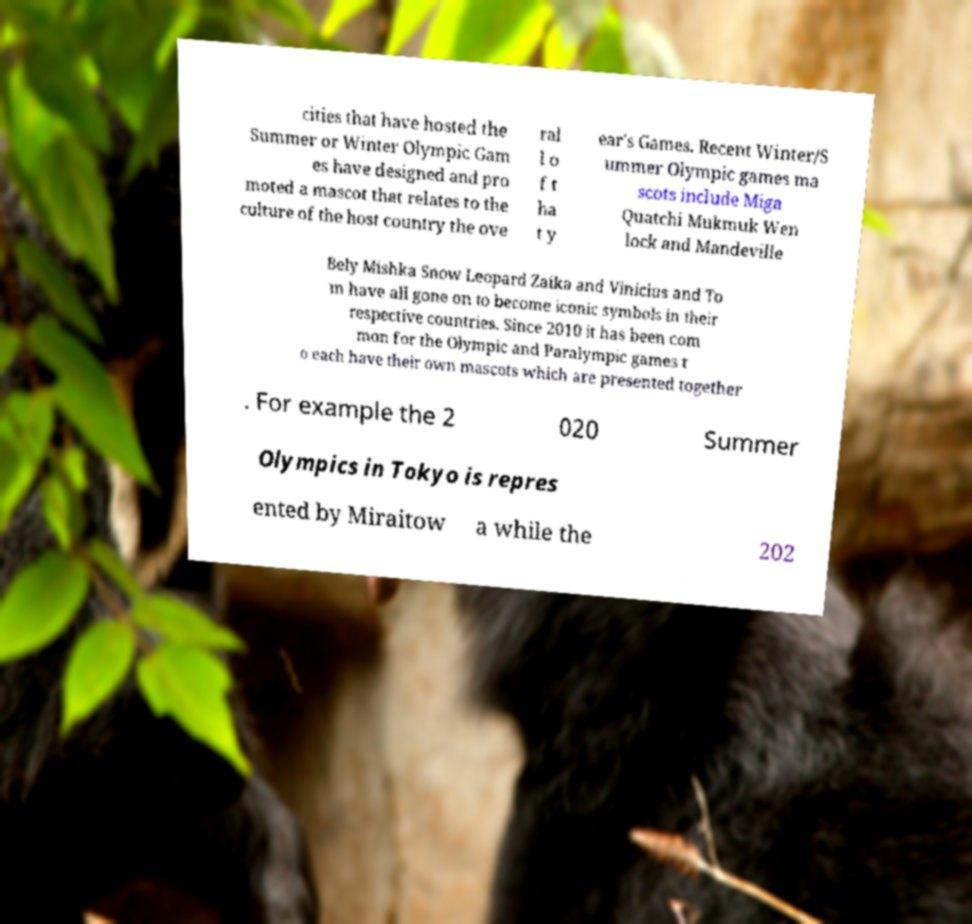Could you extract and type out the text from this image? cities that have hosted the Summer or Winter Olympic Gam es have designed and pro moted a mascot that relates to the culture of the host country the ove ral l o f t ha t y ear's Games. Recent Winter/S ummer Olympic games ma scots include Miga Quatchi Mukmuk Wen lock and Mandeville Bely Mishka Snow Leopard Zaika and Vinicius and To m have all gone on to become iconic symbols in their respective countries. Since 2010 it has been com mon for the Olympic and Paralympic games t o each have their own mascots which are presented together . For example the 2 020 Summer Olympics in Tokyo is repres ented by Miraitow a while the 202 